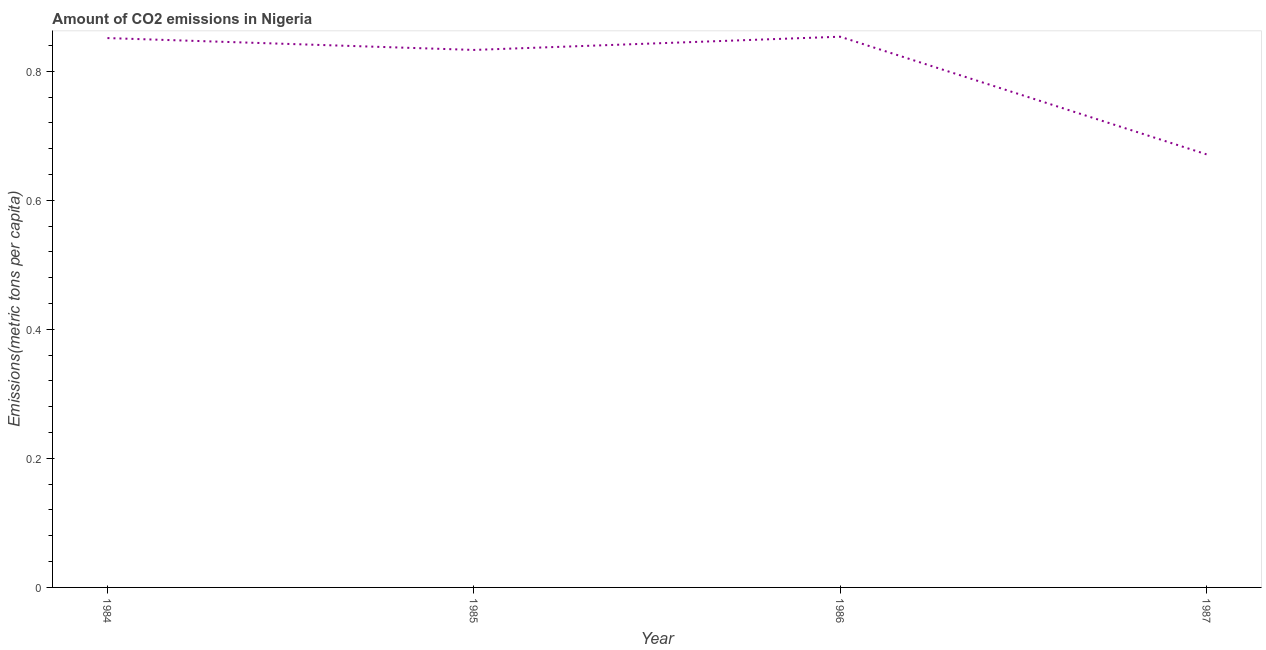What is the amount of co2 emissions in 1986?
Keep it short and to the point. 0.85. Across all years, what is the maximum amount of co2 emissions?
Your answer should be very brief. 0.85. Across all years, what is the minimum amount of co2 emissions?
Your answer should be very brief. 0.67. What is the sum of the amount of co2 emissions?
Keep it short and to the point. 3.21. What is the difference between the amount of co2 emissions in 1985 and 1986?
Provide a succinct answer. -0.02. What is the average amount of co2 emissions per year?
Offer a very short reply. 0.8. What is the median amount of co2 emissions?
Your answer should be very brief. 0.84. What is the ratio of the amount of co2 emissions in 1985 to that in 1987?
Your answer should be very brief. 1.24. Is the difference between the amount of co2 emissions in 1984 and 1987 greater than the difference between any two years?
Offer a very short reply. No. What is the difference between the highest and the second highest amount of co2 emissions?
Your answer should be very brief. 0. Is the sum of the amount of co2 emissions in 1984 and 1986 greater than the maximum amount of co2 emissions across all years?
Keep it short and to the point. Yes. What is the difference between the highest and the lowest amount of co2 emissions?
Your answer should be compact. 0.18. In how many years, is the amount of co2 emissions greater than the average amount of co2 emissions taken over all years?
Give a very brief answer. 3. How many years are there in the graph?
Offer a terse response. 4. Does the graph contain any zero values?
Offer a terse response. No. What is the title of the graph?
Make the answer very short. Amount of CO2 emissions in Nigeria. What is the label or title of the X-axis?
Your response must be concise. Year. What is the label or title of the Y-axis?
Offer a very short reply. Emissions(metric tons per capita). What is the Emissions(metric tons per capita) in 1984?
Your response must be concise. 0.85. What is the Emissions(metric tons per capita) of 1985?
Your answer should be compact. 0.83. What is the Emissions(metric tons per capita) of 1986?
Your answer should be compact. 0.85. What is the Emissions(metric tons per capita) of 1987?
Provide a short and direct response. 0.67. What is the difference between the Emissions(metric tons per capita) in 1984 and 1985?
Make the answer very short. 0.02. What is the difference between the Emissions(metric tons per capita) in 1984 and 1986?
Keep it short and to the point. -0. What is the difference between the Emissions(metric tons per capita) in 1984 and 1987?
Your answer should be very brief. 0.18. What is the difference between the Emissions(metric tons per capita) in 1985 and 1986?
Make the answer very short. -0.02. What is the difference between the Emissions(metric tons per capita) in 1985 and 1987?
Give a very brief answer. 0.16. What is the difference between the Emissions(metric tons per capita) in 1986 and 1987?
Offer a terse response. 0.18. What is the ratio of the Emissions(metric tons per capita) in 1984 to that in 1985?
Keep it short and to the point. 1.02. What is the ratio of the Emissions(metric tons per capita) in 1984 to that in 1986?
Provide a short and direct response. 1. What is the ratio of the Emissions(metric tons per capita) in 1984 to that in 1987?
Offer a very short reply. 1.27. What is the ratio of the Emissions(metric tons per capita) in 1985 to that in 1986?
Offer a terse response. 0.98. What is the ratio of the Emissions(metric tons per capita) in 1985 to that in 1987?
Your answer should be compact. 1.24. What is the ratio of the Emissions(metric tons per capita) in 1986 to that in 1987?
Keep it short and to the point. 1.27. 